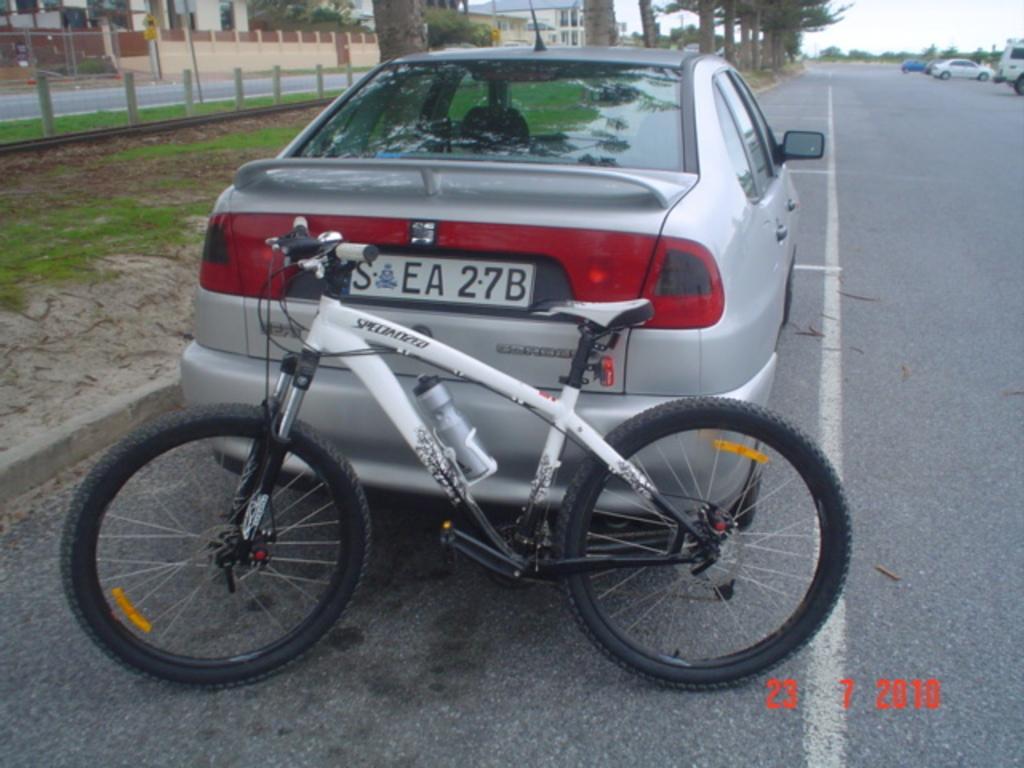Describe this image in one or two sentences. In this picture we can see a bicycle and few cars on the road, beside to the road we can find few trees, pillars and grass, in the background we can see few houses. 